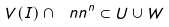Convert formula to latex. <formula><loc_0><loc_0><loc_500><loc_500>V ( I ) \cap \ n n ^ { n } \subset U \cup W</formula> 